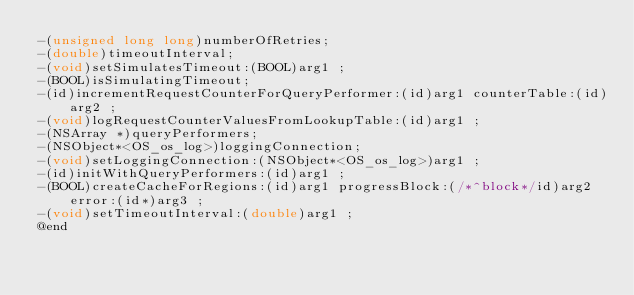Convert code to text. <code><loc_0><loc_0><loc_500><loc_500><_C_>-(unsigned long long)numberOfRetries;
-(double)timeoutInterval;
-(void)setSimulatesTimeout:(BOOL)arg1 ;
-(BOOL)isSimulatingTimeout;
-(id)incrementRequestCounterForQueryPerformer:(id)arg1 counterTable:(id)arg2 ;
-(void)logRequestCounterValuesFromLookupTable:(id)arg1 ;
-(NSArray *)queryPerformers;
-(NSObject*<OS_os_log>)loggingConnection;
-(void)setLoggingConnection:(NSObject*<OS_os_log>)arg1 ;
-(id)initWithQueryPerformers:(id)arg1 ;
-(BOOL)createCacheForRegions:(id)arg1 progressBlock:(/*^block*/id)arg2 error:(id*)arg3 ;
-(void)setTimeoutInterval:(double)arg1 ;
@end

</code> 